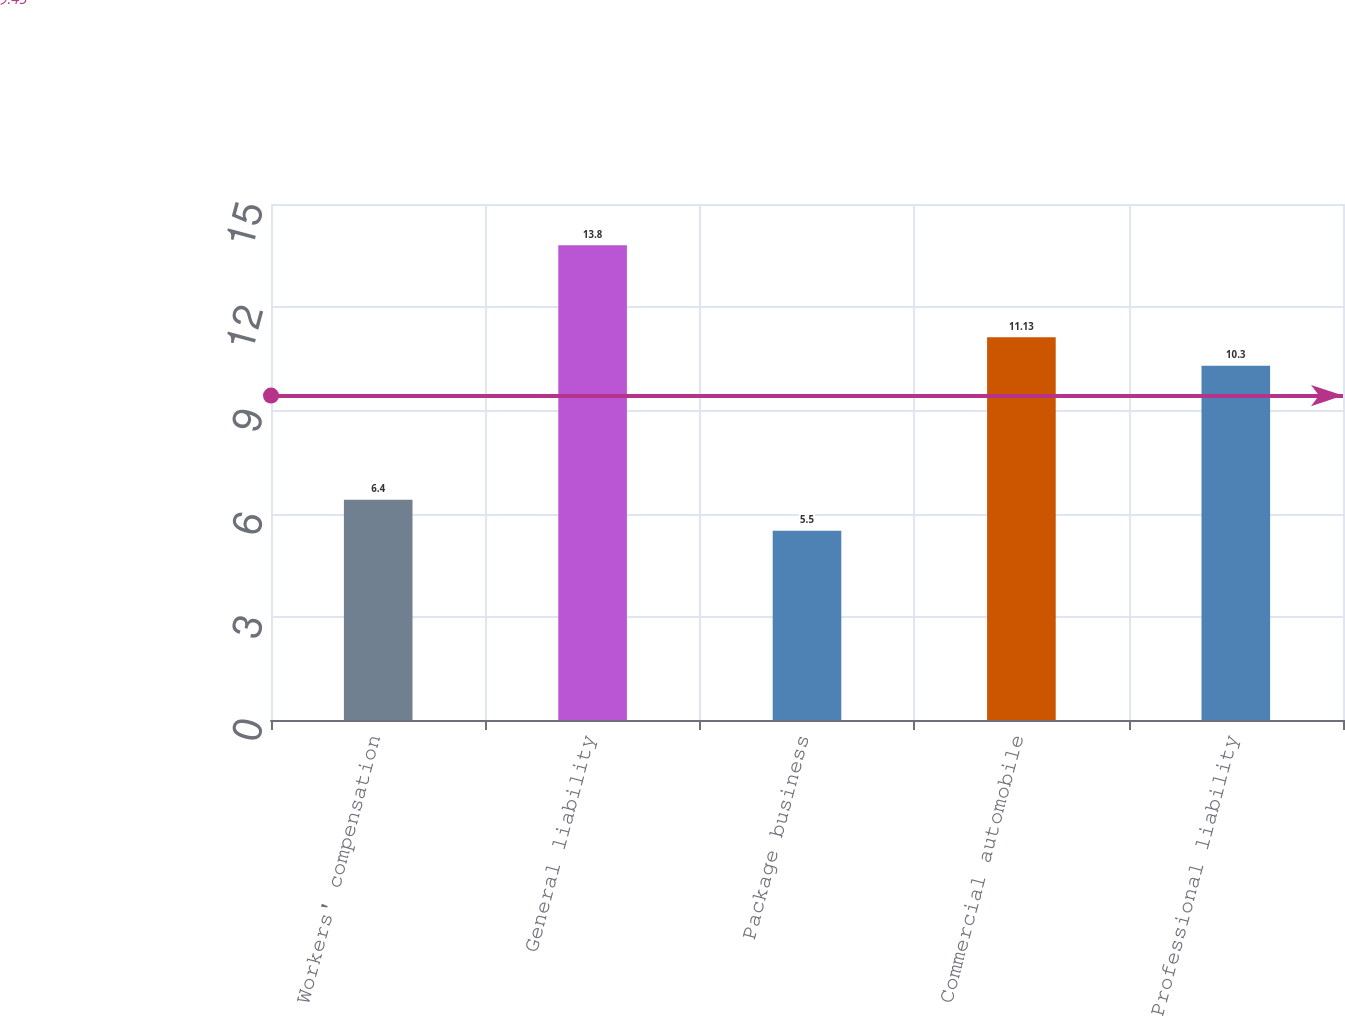Convert chart. <chart><loc_0><loc_0><loc_500><loc_500><bar_chart><fcel>Workers' compensation<fcel>General liability<fcel>Package business<fcel>Commercial automobile<fcel>Professional liability<nl><fcel>6.4<fcel>13.8<fcel>5.5<fcel>11.13<fcel>10.3<nl></chart> 